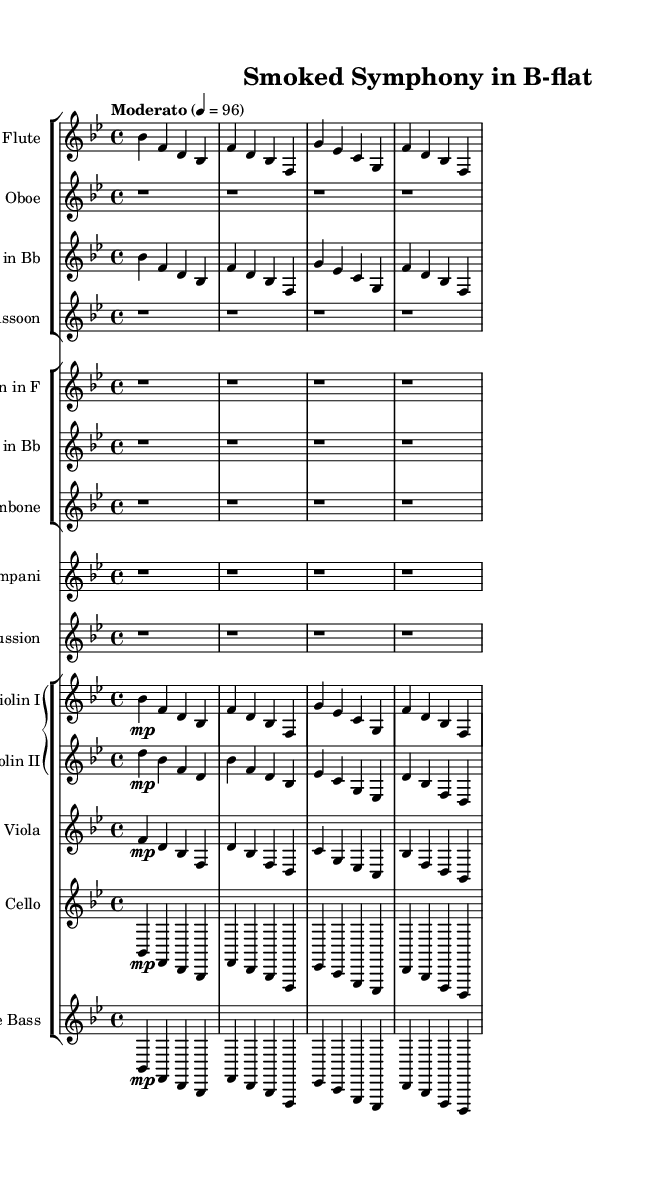What is the key signature of this symphony? The key signature is B-flat major, which has two flats shown at the beginning of the staff.
Answer: B-flat major What is the time signature of this piece? The time signature is indicated by the fraction at the beginning of the score, which shows there are four beats per measure with the quarter note receiving one beat.
Answer: 4/4 What is the tempo marking for this symphony? The tempo is described by the marking at the beginning, which indicates a moderate speed. The specific beats per minute are also given.
Answer: Moderato 4 = 96 How many different instruments are used in this score? By counting the number of distinct parts represented in the score, we can identify that there are a total of fifteen separate instrument parts listed.
Answer: Fifteen What is the first note played by the flute? Looking at the flute part written on the staff shows the first note is B-flat, which is indicated at the start of the flute melody.
Answer: B-flat Which instrument has a rest for the entire score? The rest markings are visible in the score, particularly for the oboe, indicating it does not play during the entire piece.
Answer: Oboe What unique barbecue flavor is represented by the use of woodwinds in the symphony? The woodwinds, by their warm and soft timbre, can be interpreted as representing the savory and sweet flavor profiles often used in marinades and glazes, typical of barbecue cooking techniques.
Answer: Savory-sweet 